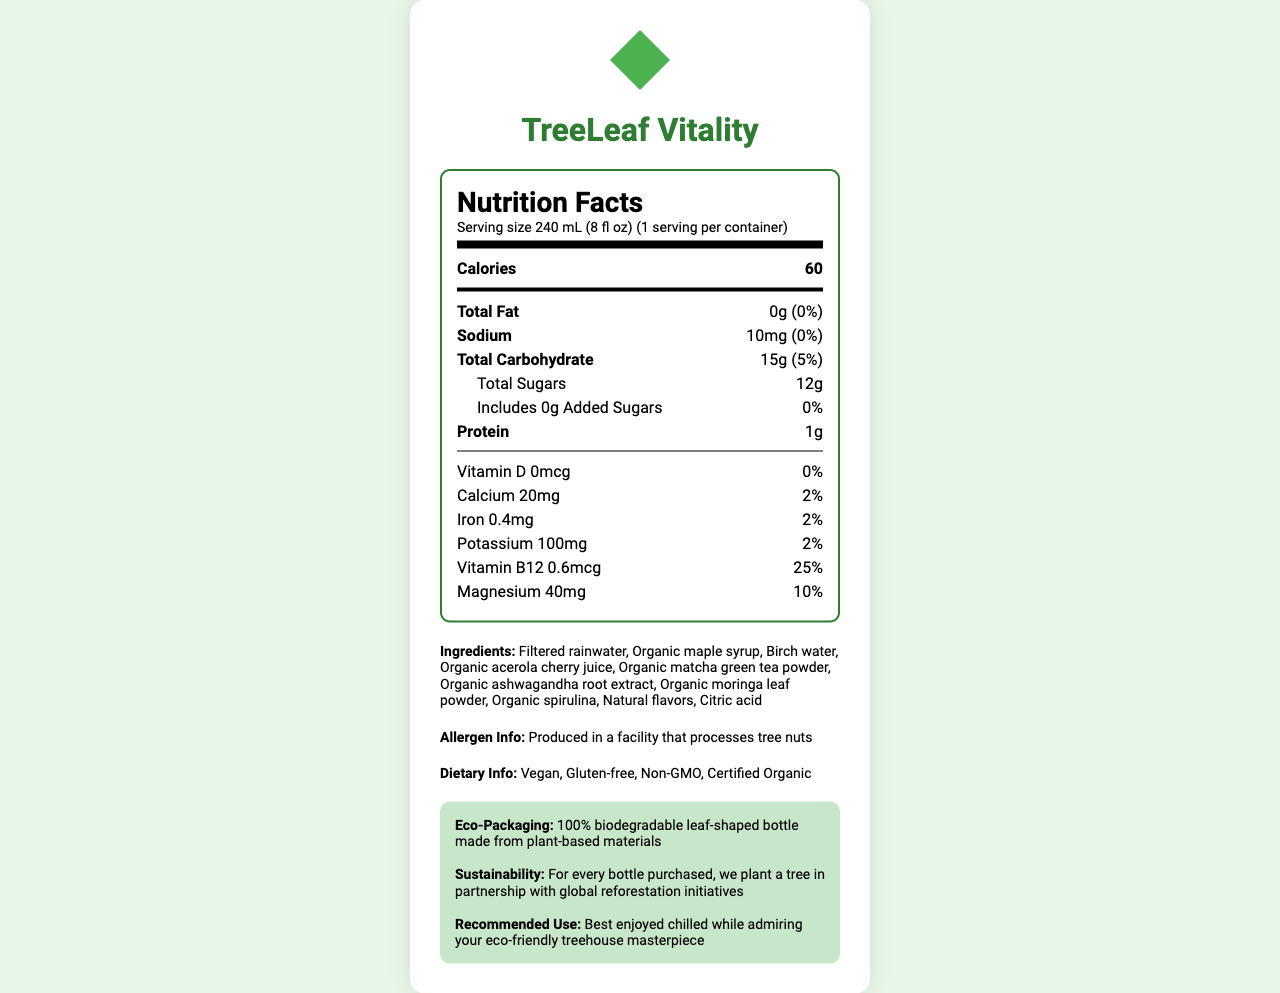what is the serving size of TreeLeaf Vitality? The serving size is clearly stated as 240 mL (8 fl oz).
Answer: 240 mL (8 fl oz) how many calories does a serving of TreeLeaf Vitality contain? The document lists the calorie content as 60.
Answer: 60 what is the amount of total fat in a serving? The total fat amount is given as 0g in the document.
Answer: 0g how much sodium is there in a serving of TreeLeaf Vitality? Sodium content per serving is 10mg as mentioned.
Answer: 10mg what are the ingredients used in TreeLeaf Vitality? The document lists all the ingredients under the Ingredients section.
Answer: Filtered rainwater, Organic maple syrup, Birch water, Organic acerola cherry juice, Organic matcha green tea powder, Organic ashwagandha root extract, Organic moringa leaf powder, Organic spirulina, Natural flavors, Citric acid. how much protein does TreeLeaf Vitality provide per serving? The protein content is mentioned as 1g per serving.
Answer: 1g is TreeLeaf Vitality suitable for vegans? The dietary information lists 'Vegan' indicating the product is suitable for vegans.
Answer: Yes does TreeLeaf Vitality contain any added sugars? The document states 'Includes 0g Added Sugars'.
Answer: No how much Vitamin B12 is in a serving of TreeLeaf Vitality? The amount of Vitamin B12 per serving is listed as 0.6mcg in the document.
Answer: 0.6mcg which of the following is an ingredient in TreeLeaf Vitality? A. Organic maca powder B. Organic ashwagandha root extract C. Organic chia seeds The ingredients list includes Organic ashwagandha root extract.
Answer: B how many servings are in one container of TreeLeaf Vitality? A. 1 B. 2 C. 3 The document mentions that there is 1 serving per container.
Answer: A does TreeLeaf Vitality contain gluten? The dietary info section specifies that the product is gluten-free.
Answer: No why is TreeLeaf Vitality considered eco-friendly? The eco-packaging and sustainability statements explain the eco-friendly attributes of the product.
Answer: It uses 100% biodegradable leaf-shaped bottle made from plant-based materials and plants a tree for every bottle purchased. describe the main idea of the document. The entire document outlines the nutrition facts, ingredients, dietary suitability, allergen information, eco-packaging, and sustainability initiatives related to TreeLeaf Vitality, highlighting both its health benefits and ecological impact.
Answer: The document provides detailed nutrition information, ingredients, dietary info, and eco-conscious aspects of TreeLeaf Vitality, a sustainable energy drink. It emphasizes health benefits and environmental sustainability. what is the origin of the filtered water used in TreeLeaf Vitality? The document only mentions "Filtered rainwater" without providing location-specific details about its origin.
Answer: Cannot be determined 